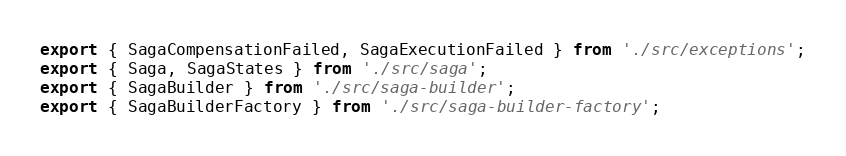Convert code to text. <code><loc_0><loc_0><loc_500><loc_500><_TypeScript_>export { SagaCompensationFailed, SagaExecutionFailed } from './src/exceptions';
export { Saga, SagaStates } from './src/saga';
export { SagaBuilder } from './src/saga-builder';
export { SagaBuilderFactory } from './src/saga-builder-factory';
</code> 